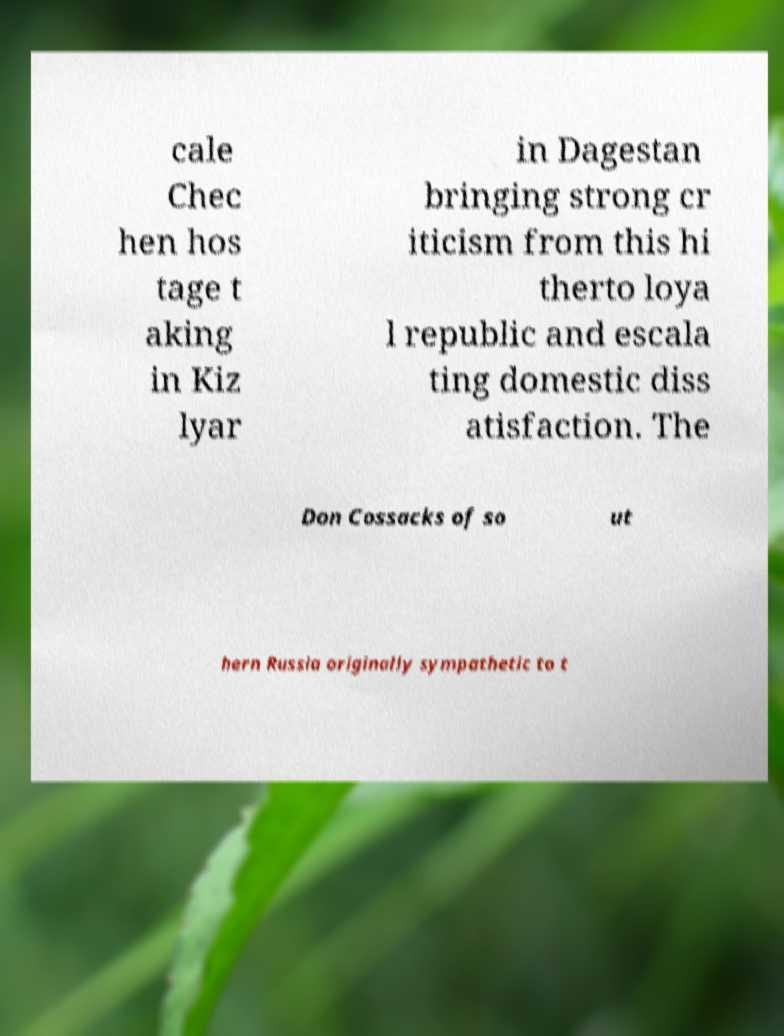Can you read and provide the text displayed in the image?This photo seems to have some interesting text. Can you extract and type it out for me? cale Chec hen hos tage t aking in Kiz lyar in Dagestan bringing strong cr iticism from this hi therto loya l republic and escala ting domestic diss atisfaction. The Don Cossacks of so ut hern Russia originally sympathetic to t 